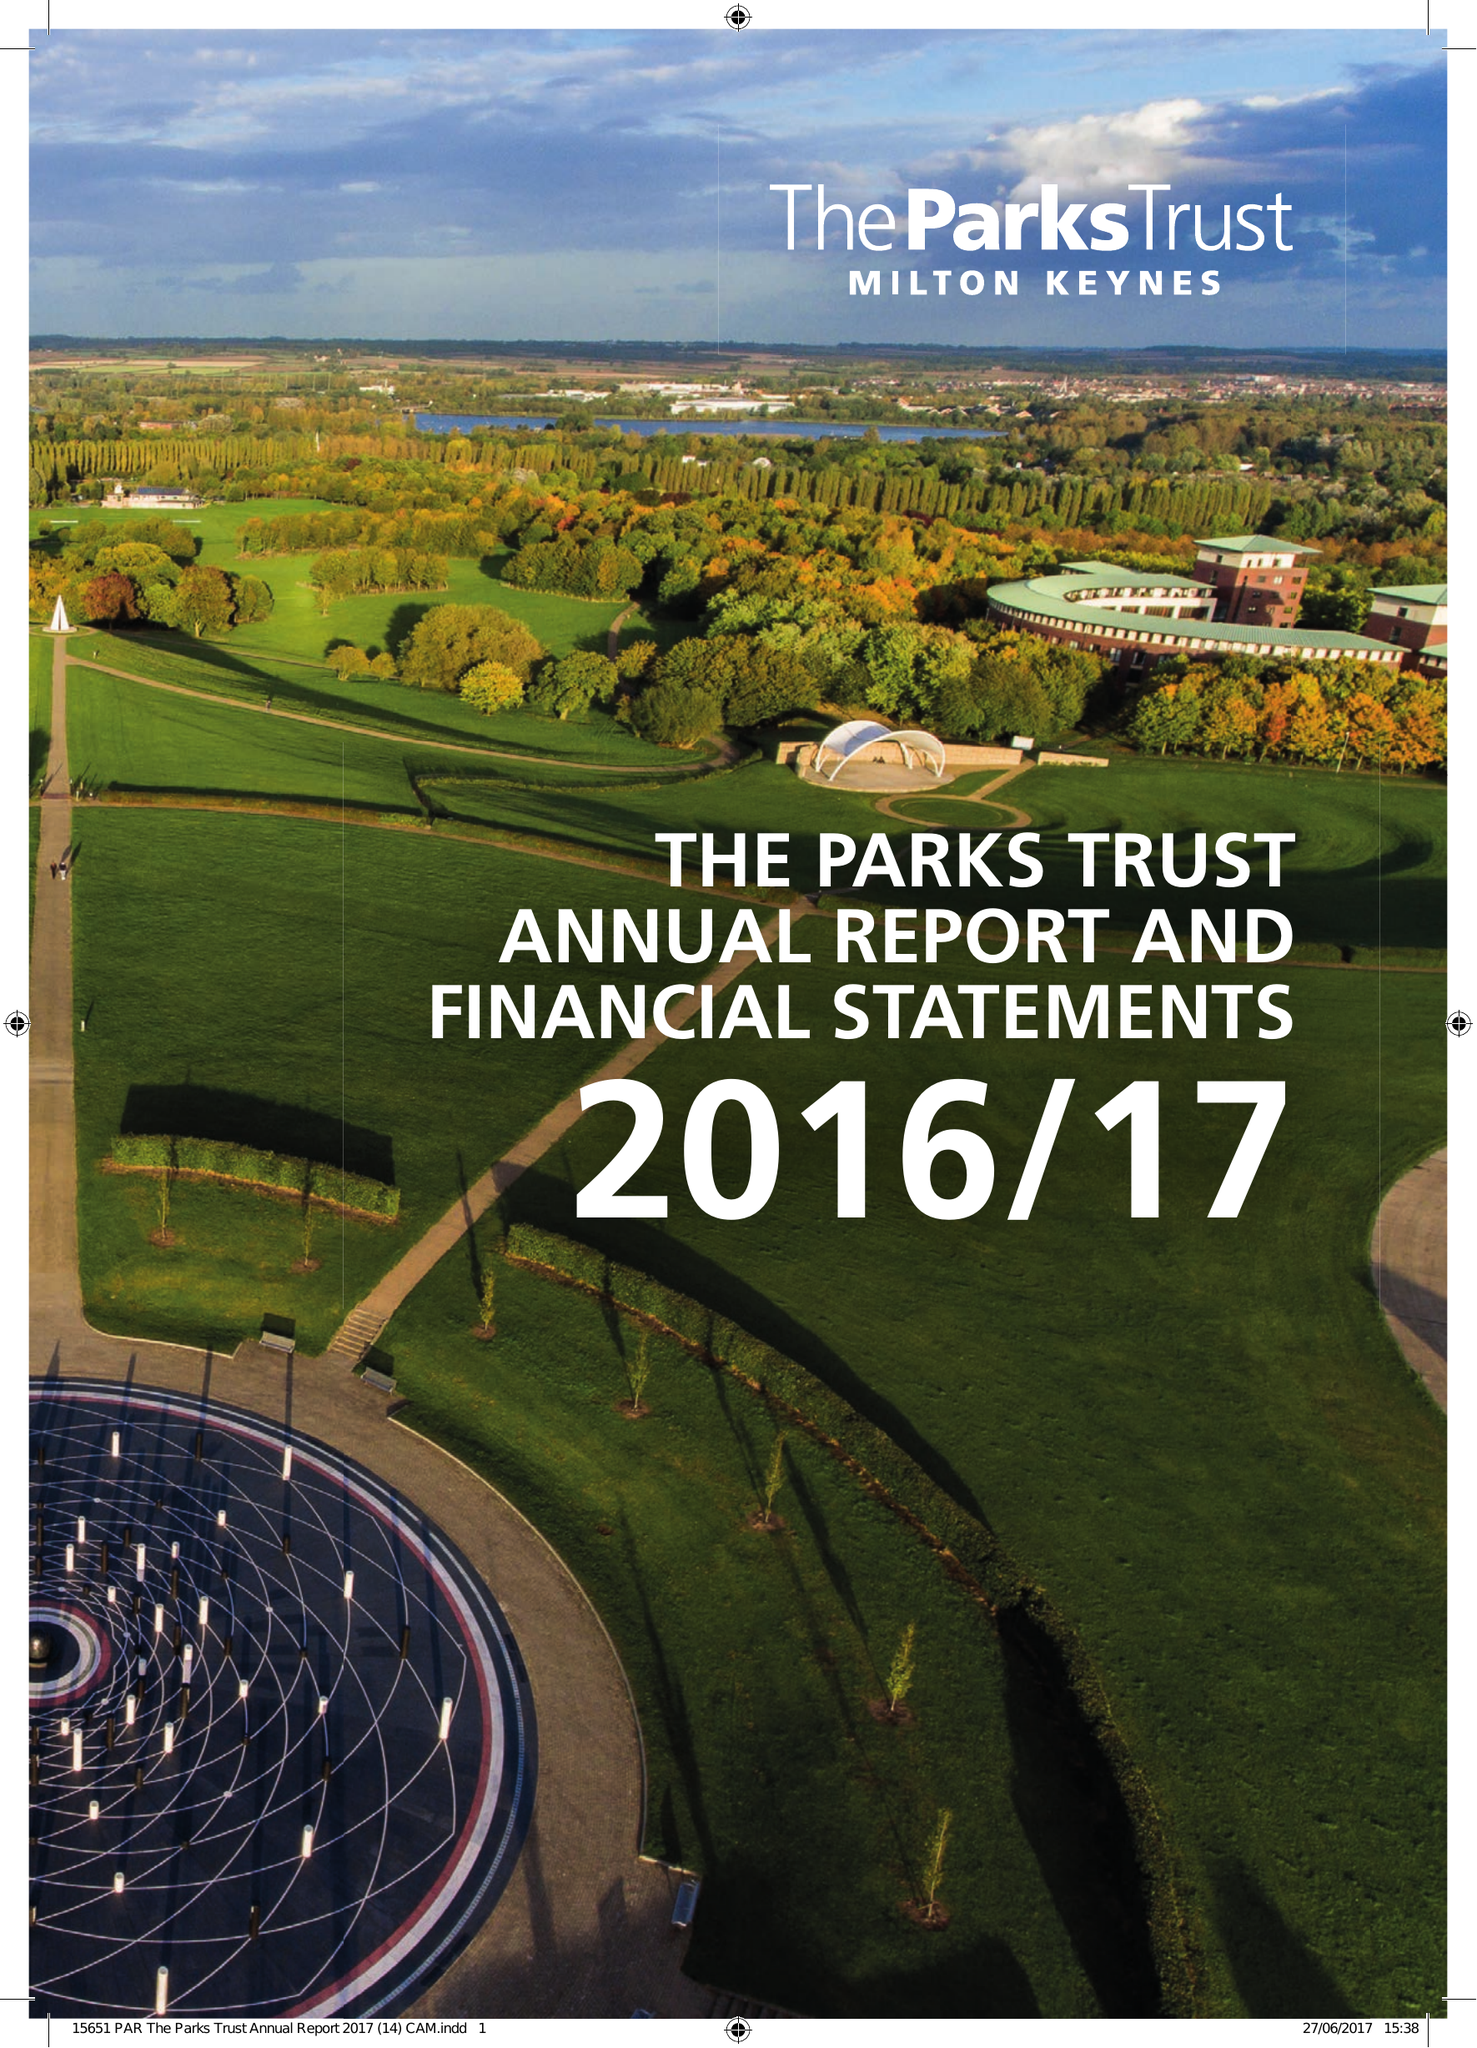What is the value for the charity_name?
Answer the question using a single word or phrase. Milton Keynes Parks Trust Ltd. 